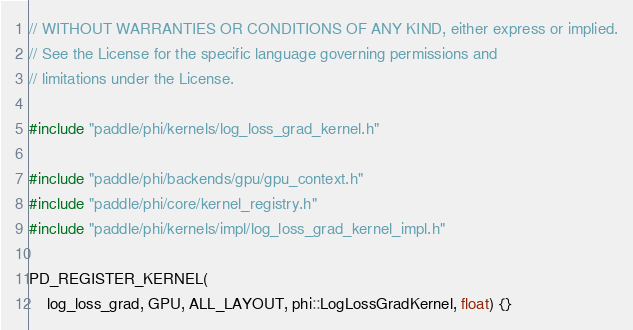Convert code to text. <code><loc_0><loc_0><loc_500><loc_500><_Cuda_>// WITHOUT WARRANTIES OR CONDITIONS OF ANY KIND, either express or implied.
// See the License for the specific language governing permissions and
// limitations under the License.

#include "paddle/phi/kernels/log_loss_grad_kernel.h"

#include "paddle/phi/backends/gpu/gpu_context.h"
#include "paddle/phi/core/kernel_registry.h"
#include "paddle/phi/kernels/impl/log_loss_grad_kernel_impl.h"

PD_REGISTER_KERNEL(
    log_loss_grad, GPU, ALL_LAYOUT, phi::LogLossGradKernel, float) {}
</code> 